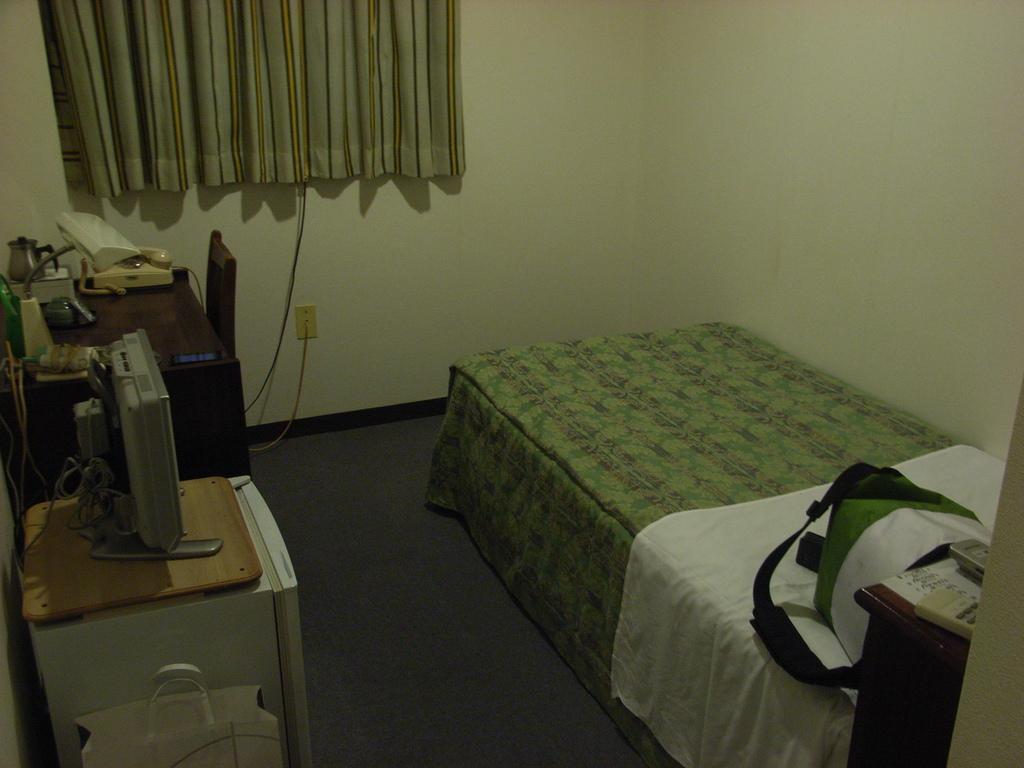How would you summarize this image in a sentence or two? In this image we can see the bed, curtain. And we can see a bag and some objects on the bed. And we can see the monitor. And we can see the lamp, telephone, chair and some other wooden objects. 